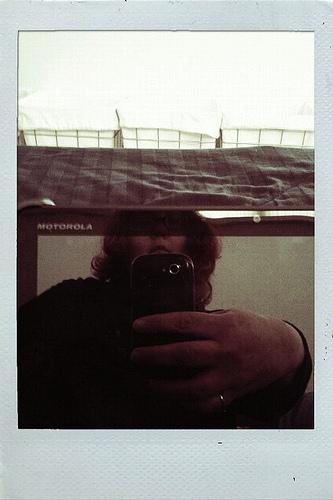Give a brief description of what the main character in the image looks like and their action. The woman with brown, short hair and glasses, dressed in black, is snapping a photo using her mobile device. Enumerate the primary person's features and action displayed in the image. A short-haired woman in black clothing and glasses is seen taking a picture with a silver and black cell phone. Narrate the appearance and ongoing activity of the individual in the image. A lady with brown hair and spectacles, clad in a black garment, is clicking a photo with her cellular phone. Mention the primary person's appearance and activity in the image. A woman with short brown hair, wearing glasses and a black shirt, is taking a picture using her black and silver phone. Provide a brief portrayal of the main individual's look and action in the photograph. A bespectacled brunette attired in black is engaged in capturing an image through her mobile phone. Describe the lead figure's appearance and ongoing pursuit in the picture. The main subject is a brown-haired woman wearing glasses and a black shirt, engaged in shooting a photo with her phone. What is the central figure in the image doing, and provide details about their appearance. A woman donning glasses, with curly brown hair and black attire, is capturing a photo using her cellphone. Depict the central character's looks and activity showcased in the image. A short brown-haired female clad in black and eyeglasses is pictured taking a snap using her black and silver cellphone. In a succinct manner, describe the key person in the image along with their visual attributes and task. Brunette lady in glasses and a black outfit is photographing a scene with her smartphone. Identify the primary subject in the image and describe their looks and activity. The chief character is a woman having short brown hair and eyeglasses, wearing a black top, and engaged in photographing using her phone. 